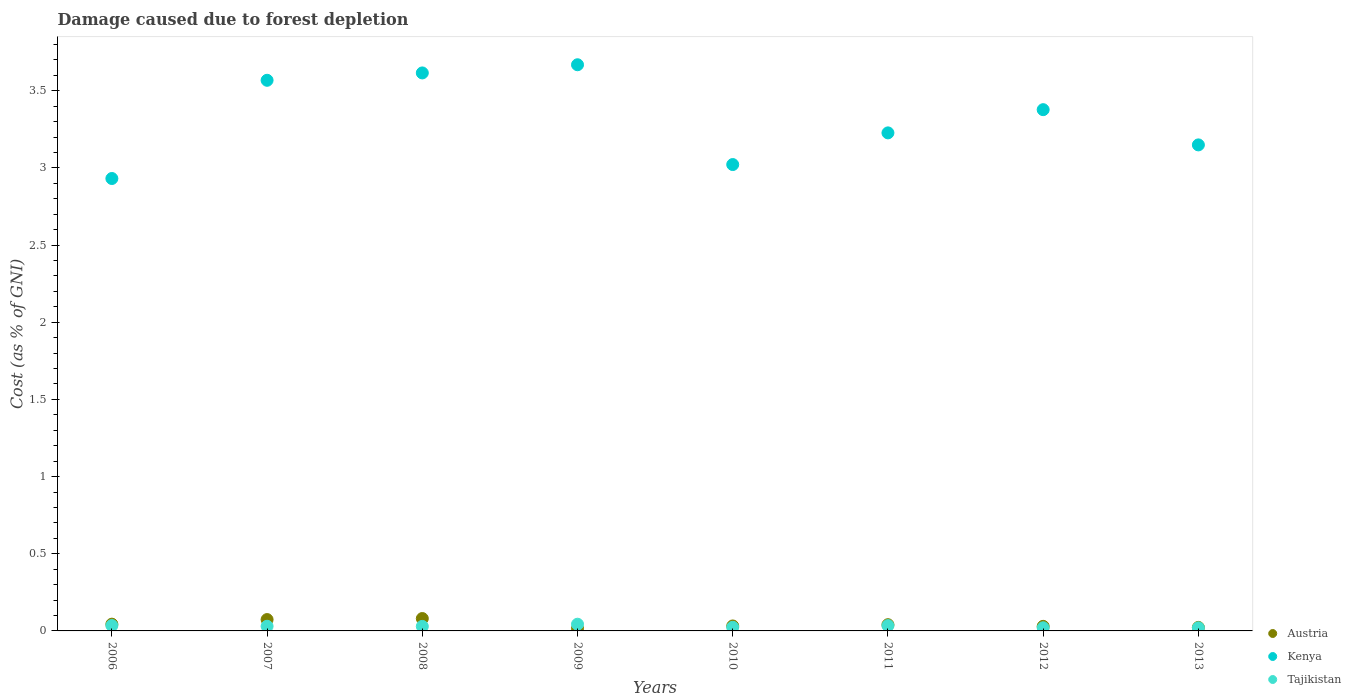How many different coloured dotlines are there?
Your answer should be very brief. 3. What is the cost of damage caused due to forest depletion in Kenya in 2007?
Keep it short and to the point. 3.57. Across all years, what is the maximum cost of damage caused due to forest depletion in Kenya?
Give a very brief answer. 3.67. Across all years, what is the minimum cost of damage caused due to forest depletion in Tajikistan?
Keep it short and to the point. 0.02. In which year was the cost of damage caused due to forest depletion in Tajikistan minimum?
Keep it short and to the point. 2013. What is the total cost of damage caused due to forest depletion in Tajikistan in the graph?
Offer a very short reply. 0.24. What is the difference between the cost of damage caused due to forest depletion in Austria in 2008 and that in 2010?
Ensure brevity in your answer.  0.05. What is the difference between the cost of damage caused due to forest depletion in Kenya in 2011 and the cost of damage caused due to forest depletion in Austria in 2009?
Provide a succinct answer. 3.21. What is the average cost of damage caused due to forest depletion in Tajikistan per year?
Your answer should be compact. 0.03. In the year 2012, what is the difference between the cost of damage caused due to forest depletion in Tajikistan and cost of damage caused due to forest depletion in Austria?
Your answer should be compact. -0.01. What is the ratio of the cost of damage caused due to forest depletion in Austria in 2012 to that in 2013?
Offer a very short reply. 1.3. Is the cost of damage caused due to forest depletion in Austria in 2007 less than that in 2008?
Provide a succinct answer. Yes. What is the difference between the highest and the second highest cost of damage caused due to forest depletion in Tajikistan?
Provide a succinct answer. 0.01. What is the difference between the highest and the lowest cost of damage caused due to forest depletion in Austria?
Make the answer very short. 0.06. Does the cost of damage caused due to forest depletion in Tajikistan monotonically increase over the years?
Offer a terse response. No. Is the cost of damage caused due to forest depletion in Tajikistan strictly greater than the cost of damage caused due to forest depletion in Austria over the years?
Give a very brief answer. No. How many dotlines are there?
Provide a short and direct response. 3. What is the difference between two consecutive major ticks on the Y-axis?
Your answer should be very brief. 0.5. Are the values on the major ticks of Y-axis written in scientific E-notation?
Your answer should be compact. No. Does the graph contain any zero values?
Your answer should be very brief. No. How are the legend labels stacked?
Offer a terse response. Vertical. What is the title of the graph?
Your response must be concise. Damage caused due to forest depletion. Does "Isle of Man" appear as one of the legend labels in the graph?
Your response must be concise. No. What is the label or title of the Y-axis?
Your response must be concise. Cost (as % of GNI). What is the Cost (as % of GNI) of Austria in 2006?
Offer a terse response. 0.04. What is the Cost (as % of GNI) in Kenya in 2006?
Provide a short and direct response. 2.93. What is the Cost (as % of GNI) of Tajikistan in 2006?
Provide a short and direct response. 0.03. What is the Cost (as % of GNI) in Austria in 2007?
Ensure brevity in your answer.  0.07. What is the Cost (as % of GNI) in Kenya in 2007?
Make the answer very short. 3.57. What is the Cost (as % of GNI) of Tajikistan in 2007?
Your answer should be compact. 0.03. What is the Cost (as % of GNI) of Austria in 2008?
Keep it short and to the point. 0.08. What is the Cost (as % of GNI) of Kenya in 2008?
Provide a succinct answer. 3.62. What is the Cost (as % of GNI) of Tajikistan in 2008?
Keep it short and to the point. 0.03. What is the Cost (as % of GNI) of Austria in 2009?
Your response must be concise. 0.02. What is the Cost (as % of GNI) in Kenya in 2009?
Offer a terse response. 3.67. What is the Cost (as % of GNI) in Tajikistan in 2009?
Give a very brief answer. 0.04. What is the Cost (as % of GNI) of Austria in 2010?
Keep it short and to the point. 0.03. What is the Cost (as % of GNI) of Kenya in 2010?
Your response must be concise. 3.02. What is the Cost (as % of GNI) of Tajikistan in 2010?
Ensure brevity in your answer.  0.02. What is the Cost (as % of GNI) of Austria in 2011?
Give a very brief answer. 0.04. What is the Cost (as % of GNI) of Kenya in 2011?
Provide a short and direct response. 3.23. What is the Cost (as % of GNI) in Tajikistan in 2011?
Provide a short and direct response. 0.03. What is the Cost (as % of GNI) of Austria in 2012?
Offer a terse response. 0.03. What is the Cost (as % of GNI) in Kenya in 2012?
Your answer should be compact. 3.38. What is the Cost (as % of GNI) in Tajikistan in 2012?
Offer a terse response. 0.02. What is the Cost (as % of GNI) in Austria in 2013?
Keep it short and to the point. 0.02. What is the Cost (as % of GNI) of Kenya in 2013?
Offer a very short reply. 3.15. What is the Cost (as % of GNI) in Tajikistan in 2013?
Keep it short and to the point. 0.02. Across all years, what is the maximum Cost (as % of GNI) in Austria?
Provide a succinct answer. 0.08. Across all years, what is the maximum Cost (as % of GNI) of Kenya?
Make the answer very short. 3.67. Across all years, what is the maximum Cost (as % of GNI) in Tajikistan?
Your response must be concise. 0.04. Across all years, what is the minimum Cost (as % of GNI) of Austria?
Your answer should be compact. 0.02. Across all years, what is the minimum Cost (as % of GNI) of Kenya?
Your answer should be compact. 2.93. Across all years, what is the minimum Cost (as % of GNI) in Tajikistan?
Ensure brevity in your answer.  0.02. What is the total Cost (as % of GNI) in Austria in the graph?
Ensure brevity in your answer.  0.34. What is the total Cost (as % of GNI) in Kenya in the graph?
Keep it short and to the point. 26.56. What is the total Cost (as % of GNI) in Tajikistan in the graph?
Give a very brief answer. 0.24. What is the difference between the Cost (as % of GNI) of Austria in 2006 and that in 2007?
Offer a very short reply. -0.03. What is the difference between the Cost (as % of GNI) in Kenya in 2006 and that in 2007?
Make the answer very short. -0.64. What is the difference between the Cost (as % of GNI) of Tajikistan in 2006 and that in 2007?
Offer a terse response. 0. What is the difference between the Cost (as % of GNI) in Austria in 2006 and that in 2008?
Provide a succinct answer. -0.04. What is the difference between the Cost (as % of GNI) in Kenya in 2006 and that in 2008?
Ensure brevity in your answer.  -0.68. What is the difference between the Cost (as % of GNI) of Tajikistan in 2006 and that in 2008?
Provide a short and direct response. 0.01. What is the difference between the Cost (as % of GNI) in Austria in 2006 and that in 2009?
Make the answer very short. 0.03. What is the difference between the Cost (as % of GNI) of Kenya in 2006 and that in 2009?
Keep it short and to the point. -0.74. What is the difference between the Cost (as % of GNI) of Tajikistan in 2006 and that in 2009?
Your answer should be very brief. -0.01. What is the difference between the Cost (as % of GNI) of Austria in 2006 and that in 2010?
Your response must be concise. 0.01. What is the difference between the Cost (as % of GNI) in Kenya in 2006 and that in 2010?
Your answer should be compact. -0.09. What is the difference between the Cost (as % of GNI) in Tajikistan in 2006 and that in 2010?
Provide a short and direct response. 0.01. What is the difference between the Cost (as % of GNI) of Austria in 2006 and that in 2011?
Your answer should be compact. 0. What is the difference between the Cost (as % of GNI) in Kenya in 2006 and that in 2011?
Your answer should be compact. -0.3. What is the difference between the Cost (as % of GNI) of Tajikistan in 2006 and that in 2011?
Your answer should be very brief. 0. What is the difference between the Cost (as % of GNI) of Austria in 2006 and that in 2012?
Offer a terse response. 0.01. What is the difference between the Cost (as % of GNI) of Kenya in 2006 and that in 2012?
Keep it short and to the point. -0.45. What is the difference between the Cost (as % of GNI) in Tajikistan in 2006 and that in 2012?
Your answer should be very brief. 0.01. What is the difference between the Cost (as % of GNI) of Austria in 2006 and that in 2013?
Offer a very short reply. 0.02. What is the difference between the Cost (as % of GNI) of Kenya in 2006 and that in 2013?
Offer a very short reply. -0.22. What is the difference between the Cost (as % of GNI) in Tajikistan in 2006 and that in 2013?
Keep it short and to the point. 0.01. What is the difference between the Cost (as % of GNI) in Austria in 2007 and that in 2008?
Offer a very short reply. -0.01. What is the difference between the Cost (as % of GNI) of Kenya in 2007 and that in 2008?
Provide a succinct answer. -0.05. What is the difference between the Cost (as % of GNI) of Tajikistan in 2007 and that in 2008?
Keep it short and to the point. 0. What is the difference between the Cost (as % of GNI) of Austria in 2007 and that in 2009?
Offer a very short reply. 0.06. What is the difference between the Cost (as % of GNI) of Kenya in 2007 and that in 2009?
Your answer should be very brief. -0.1. What is the difference between the Cost (as % of GNI) in Tajikistan in 2007 and that in 2009?
Give a very brief answer. -0.01. What is the difference between the Cost (as % of GNI) in Austria in 2007 and that in 2010?
Your answer should be very brief. 0.04. What is the difference between the Cost (as % of GNI) in Kenya in 2007 and that in 2010?
Make the answer very short. 0.55. What is the difference between the Cost (as % of GNI) in Tajikistan in 2007 and that in 2010?
Ensure brevity in your answer.  0.01. What is the difference between the Cost (as % of GNI) in Kenya in 2007 and that in 2011?
Make the answer very short. 0.34. What is the difference between the Cost (as % of GNI) of Tajikistan in 2007 and that in 2011?
Your answer should be compact. -0. What is the difference between the Cost (as % of GNI) in Austria in 2007 and that in 2012?
Keep it short and to the point. 0.04. What is the difference between the Cost (as % of GNI) in Kenya in 2007 and that in 2012?
Provide a short and direct response. 0.19. What is the difference between the Cost (as % of GNI) of Tajikistan in 2007 and that in 2012?
Make the answer very short. 0.01. What is the difference between the Cost (as % of GNI) in Austria in 2007 and that in 2013?
Keep it short and to the point. 0.05. What is the difference between the Cost (as % of GNI) in Kenya in 2007 and that in 2013?
Give a very brief answer. 0.42. What is the difference between the Cost (as % of GNI) in Tajikistan in 2007 and that in 2013?
Ensure brevity in your answer.  0.01. What is the difference between the Cost (as % of GNI) in Austria in 2008 and that in 2009?
Provide a short and direct response. 0.06. What is the difference between the Cost (as % of GNI) in Kenya in 2008 and that in 2009?
Provide a short and direct response. -0.05. What is the difference between the Cost (as % of GNI) of Tajikistan in 2008 and that in 2009?
Provide a succinct answer. -0.01. What is the difference between the Cost (as % of GNI) of Austria in 2008 and that in 2010?
Offer a very short reply. 0.05. What is the difference between the Cost (as % of GNI) of Kenya in 2008 and that in 2010?
Offer a very short reply. 0.59. What is the difference between the Cost (as % of GNI) of Tajikistan in 2008 and that in 2010?
Provide a succinct answer. 0.01. What is the difference between the Cost (as % of GNI) in Austria in 2008 and that in 2011?
Keep it short and to the point. 0.04. What is the difference between the Cost (as % of GNI) of Kenya in 2008 and that in 2011?
Make the answer very short. 0.39. What is the difference between the Cost (as % of GNI) in Tajikistan in 2008 and that in 2011?
Your answer should be very brief. -0.01. What is the difference between the Cost (as % of GNI) in Austria in 2008 and that in 2012?
Your answer should be compact. 0.05. What is the difference between the Cost (as % of GNI) in Kenya in 2008 and that in 2012?
Provide a succinct answer. 0.24. What is the difference between the Cost (as % of GNI) in Tajikistan in 2008 and that in 2012?
Ensure brevity in your answer.  0.01. What is the difference between the Cost (as % of GNI) in Austria in 2008 and that in 2013?
Offer a very short reply. 0.06. What is the difference between the Cost (as % of GNI) of Kenya in 2008 and that in 2013?
Offer a terse response. 0.47. What is the difference between the Cost (as % of GNI) of Tajikistan in 2008 and that in 2013?
Keep it short and to the point. 0.01. What is the difference between the Cost (as % of GNI) of Austria in 2009 and that in 2010?
Your answer should be very brief. -0.02. What is the difference between the Cost (as % of GNI) in Kenya in 2009 and that in 2010?
Offer a terse response. 0.65. What is the difference between the Cost (as % of GNI) in Tajikistan in 2009 and that in 2010?
Your answer should be very brief. 0.02. What is the difference between the Cost (as % of GNI) in Austria in 2009 and that in 2011?
Keep it short and to the point. -0.02. What is the difference between the Cost (as % of GNI) in Kenya in 2009 and that in 2011?
Give a very brief answer. 0.44. What is the difference between the Cost (as % of GNI) in Tajikistan in 2009 and that in 2011?
Provide a succinct answer. 0.01. What is the difference between the Cost (as % of GNI) of Austria in 2009 and that in 2012?
Keep it short and to the point. -0.01. What is the difference between the Cost (as % of GNI) of Kenya in 2009 and that in 2012?
Your response must be concise. 0.29. What is the difference between the Cost (as % of GNI) of Tajikistan in 2009 and that in 2012?
Your response must be concise. 0.02. What is the difference between the Cost (as % of GNI) in Austria in 2009 and that in 2013?
Offer a terse response. -0.01. What is the difference between the Cost (as % of GNI) in Kenya in 2009 and that in 2013?
Give a very brief answer. 0.52. What is the difference between the Cost (as % of GNI) in Tajikistan in 2009 and that in 2013?
Your answer should be very brief. 0.02. What is the difference between the Cost (as % of GNI) in Austria in 2010 and that in 2011?
Give a very brief answer. -0.01. What is the difference between the Cost (as % of GNI) of Kenya in 2010 and that in 2011?
Provide a short and direct response. -0.21. What is the difference between the Cost (as % of GNI) of Tajikistan in 2010 and that in 2011?
Your answer should be very brief. -0.01. What is the difference between the Cost (as % of GNI) in Austria in 2010 and that in 2012?
Provide a short and direct response. 0. What is the difference between the Cost (as % of GNI) in Kenya in 2010 and that in 2012?
Your answer should be compact. -0.36. What is the difference between the Cost (as % of GNI) of Tajikistan in 2010 and that in 2012?
Give a very brief answer. 0. What is the difference between the Cost (as % of GNI) of Austria in 2010 and that in 2013?
Your answer should be very brief. 0.01. What is the difference between the Cost (as % of GNI) in Kenya in 2010 and that in 2013?
Your answer should be very brief. -0.13. What is the difference between the Cost (as % of GNI) of Tajikistan in 2010 and that in 2013?
Offer a terse response. 0. What is the difference between the Cost (as % of GNI) in Austria in 2011 and that in 2012?
Make the answer very short. 0.01. What is the difference between the Cost (as % of GNI) in Kenya in 2011 and that in 2012?
Your answer should be compact. -0.15. What is the difference between the Cost (as % of GNI) in Tajikistan in 2011 and that in 2012?
Make the answer very short. 0.01. What is the difference between the Cost (as % of GNI) in Austria in 2011 and that in 2013?
Offer a terse response. 0.02. What is the difference between the Cost (as % of GNI) in Kenya in 2011 and that in 2013?
Your answer should be very brief. 0.08. What is the difference between the Cost (as % of GNI) in Tajikistan in 2011 and that in 2013?
Your response must be concise. 0.01. What is the difference between the Cost (as % of GNI) of Austria in 2012 and that in 2013?
Give a very brief answer. 0.01. What is the difference between the Cost (as % of GNI) of Kenya in 2012 and that in 2013?
Offer a very short reply. 0.23. What is the difference between the Cost (as % of GNI) in Austria in 2006 and the Cost (as % of GNI) in Kenya in 2007?
Keep it short and to the point. -3.52. What is the difference between the Cost (as % of GNI) in Austria in 2006 and the Cost (as % of GNI) in Tajikistan in 2007?
Make the answer very short. 0.01. What is the difference between the Cost (as % of GNI) of Kenya in 2006 and the Cost (as % of GNI) of Tajikistan in 2007?
Provide a succinct answer. 2.9. What is the difference between the Cost (as % of GNI) of Austria in 2006 and the Cost (as % of GNI) of Kenya in 2008?
Your answer should be very brief. -3.57. What is the difference between the Cost (as % of GNI) of Austria in 2006 and the Cost (as % of GNI) of Tajikistan in 2008?
Keep it short and to the point. 0.01. What is the difference between the Cost (as % of GNI) in Kenya in 2006 and the Cost (as % of GNI) in Tajikistan in 2008?
Provide a short and direct response. 2.9. What is the difference between the Cost (as % of GNI) of Austria in 2006 and the Cost (as % of GNI) of Kenya in 2009?
Offer a very short reply. -3.62. What is the difference between the Cost (as % of GNI) of Austria in 2006 and the Cost (as % of GNI) of Tajikistan in 2009?
Make the answer very short. 0. What is the difference between the Cost (as % of GNI) of Kenya in 2006 and the Cost (as % of GNI) of Tajikistan in 2009?
Offer a very short reply. 2.89. What is the difference between the Cost (as % of GNI) of Austria in 2006 and the Cost (as % of GNI) of Kenya in 2010?
Give a very brief answer. -2.98. What is the difference between the Cost (as % of GNI) of Austria in 2006 and the Cost (as % of GNI) of Tajikistan in 2010?
Your response must be concise. 0.02. What is the difference between the Cost (as % of GNI) of Kenya in 2006 and the Cost (as % of GNI) of Tajikistan in 2010?
Offer a terse response. 2.91. What is the difference between the Cost (as % of GNI) in Austria in 2006 and the Cost (as % of GNI) in Kenya in 2011?
Ensure brevity in your answer.  -3.18. What is the difference between the Cost (as % of GNI) of Austria in 2006 and the Cost (as % of GNI) of Tajikistan in 2011?
Make the answer very short. 0.01. What is the difference between the Cost (as % of GNI) in Kenya in 2006 and the Cost (as % of GNI) in Tajikistan in 2011?
Your answer should be compact. 2.9. What is the difference between the Cost (as % of GNI) of Austria in 2006 and the Cost (as % of GNI) of Kenya in 2012?
Ensure brevity in your answer.  -3.33. What is the difference between the Cost (as % of GNI) in Austria in 2006 and the Cost (as % of GNI) in Tajikistan in 2012?
Your answer should be very brief. 0.02. What is the difference between the Cost (as % of GNI) in Kenya in 2006 and the Cost (as % of GNI) in Tajikistan in 2012?
Your answer should be compact. 2.91. What is the difference between the Cost (as % of GNI) of Austria in 2006 and the Cost (as % of GNI) of Kenya in 2013?
Make the answer very short. -3.11. What is the difference between the Cost (as % of GNI) of Austria in 2006 and the Cost (as % of GNI) of Tajikistan in 2013?
Your response must be concise. 0.02. What is the difference between the Cost (as % of GNI) in Kenya in 2006 and the Cost (as % of GNI) in Tajikistan in 2013?
Provide a short and direct response. 2.91. What is the difference between the Cost (as % of GNI) in Austria in 2007 and the Cost (as % of GNI) in Kenya in 2008?
Offer a terse response. -3.54. What is the difference between the Cost (as % of GNI) in Austria in 2007 and the Cost (as % of GNI) in Tajikistan in 2008?
Your answer should be very brief. 0.04. What is the difference between the Cost (as % of GNI) in Kenya in 2007 and the Cost (as % of GNI) in Tajikistan in 2008?
Provide a short and direct response. 3.54. What is the difference between the Cost (as % of GNI) of Austria in 2007 and the Cost (as % of GNI) of Kenya in 2009?
Ensure brevity in your answer.  -3.59. What is the difference between the Cost (as % of GNI) of Austria in 2007 and the Cost (as % of GNI) of Tajikistan in 2009?
Your answer should be very brief. 0.03. What is the difference between the Cost (as % of GNI) in Kenya in 2007 and the Cost (as % of GNI) in Tajikistan in 2009?
Provide a succinct answer. 3.52. What is the difference between the Cost (as % of GNI) in Austria in 2007 and the Cost (as % of GNI) in Kenya in 2010?
Give a very brief answer. -2.95. What is the difference between the Cost (as % of GNI) in Austria in 2007 and the Cost (as % of GNI) in Tajikistan in 2010?
Offer a terse response. 0.05. What is the difference between the Cost (as % of GNI) of Kenya in 2007 and the Cost (as % of GNI) of Tajikistan in 2010?
Offer a very short reply. 3.54. What is the difference between the Cost (as % of GNI) of Austria in 2007 and the Cost (as % of GNI) of Kenya in 2011?
Make the answer very short. -3.15. What is the difference between the Cost (as % of GNI) of Austria in 2007 and the Cost (as % of GNI) of Tajikistan in 2011?
Make the answer very short. 0.04. What is the difference between the Cost (as % of GNI) of Kenya in 2007 and the Cost (as % of GNI) of Tajikistan in 2011?
Provide a succinct answer. 3.53. What is the difference between the Cost (as % of GNI) in Austria in 2007 and the Cost (as % of GNI) in Kenya in 2012?
Ensure brevity in your answer.  -3.3. What is the difference between the Cost (as % of GNI) of Austria in 2007 and the Cost (as % of GNI) of Tajikistan in 2012?
Offer a very short reply. 0.05. What is the difference between the Cost (as % of GNI) of Kenya in 2007 and the Cost (as % of GNI) of Tajikistan in 2012?
Keep it short and to the point. 3.55. What is the difference between the Cost (as % of GNI) of Austria in 2007 and the Cost (as % of GNI) of Kenya in 2013?
Make the answer very short. -3.08. What is the difference between the Cost (as % of GNI) of Austria in 2007 and the Cost (as % of GNI) of Tajikistan in 2013?
Provide a short and direct response. 0.05. What is the difference between the Cost (as % of GNI) in Kenya in 2007 and the Cost (as % of GNI) in Tajikistan in 2013?
Keep it short and to the point. 3.55. What is the difference between the Cost (as % of GNI) in Austria in 2008 and the Cost (as % of GNI) in Kenya in 2009?
Provide a succinct answer. -3.59. What is the difference between the Cost (as % of GNI) in Austria in 2008 and the Cost (as % of GNI) in Tajikistan in 2009?
Ensure brevity in your answer.  0.04. What is the difference between the Cost (as % of GNI) in Kenya in 2008 and the Cost (as % of GNI) in Tajikistan in 2009?
Your answer should be very brief. 3.57. What is the difference between the Cost (as % of GNI) in Austria in 2008 and the Cost (as % of GNI) in Kenya in 2010?
Your response must be concise. -2.94. What is the difference between the Cost (as % of GNI) in Austria in 2008 and the Cost (as % of GNI) in Tajikistan in 2010?
Ensure brevity in your answer.  0.06. What is the difference between the Cost (as % of GNI) of Kenya in 2008 and the Cost (as % of GNI) of Tajikistan in 2010?
Offer a terse response. 3.59. What is the difference between the Cost (as % of GNI) in Austria in 2008 and the Cost (as % of GNI) in Kenya in 2011?
Offer a very short reply. -3.15. What is the difference between the Cost (as % of GNI) of Austria in 2008 and the Cost (as % of GNI) of Tajikistan in 2011?
Offer a very short reply. 0.05. What is the difference between the Cost (as % of GNI) of Kenya in 2008 and the Cost (as % of GNI) of Tajikistan in 2011?
Give a very brief answer. 3.58. What is the difference between the Cost (as % of GNI) of Austria in 2008 and the Cost (as % of GNI) of Kenya in 2012?
Keep it short and to the point. -3.3. What is the difference between the Cost (as % of GNI) of Austria in 2008 and the Cost (as % of GNI) of Tajikistan in 2012?
Your answer should be compact. 0.06. What is the difference between the Cost (as % of GNI) in Kenya in 2008 and the Cost (as % of GNI) in Tajikistan in 2012?
Give a very brief answer. 3.6. What is the difference between the Cost (as % of GNI) in Austria in 2008 and the Cost (as % of GNI) in Kenya in 2013?
Your answer should be very brief. -3.07. What is the difference between the Cost (as % of GNI) in Austria in 2008 and the Cost (as % of GNI) in Tajikistan in 2013?
Ensure brevity in your answer.  0.06. What is the difference between the Cost (as % of GNI) of Kenya in 2008 and the Cost (as % of GNI) of Tajikistan in 2013?
Provide a short and direct response. 3.6. What is the difference between the Cost (as % of GNI) of Austria in 2009 and the Cost (as % of GNI) of Kenya in 2010?
Make the answer very short. -3.01. What is the difference between the Cost (as % of GNI) in Austria in 2009 and the Cost (as % of GNI) in Tajikistan in 2010?
Make the answer very short. -0.01. What is the difference between the Cost (as % of GNI) of Kenya in 2009 and the Cost (as % of GNI) of Tajikistan in 2010?
Make the answer very short. 3.64. What is the difference between the Cost (as % of GNI) of Austria in 2009 and the Cost (as % of GNI) of Kenya in 2011?
Make the answer very short. -3.21. What is the difference between the Cost (as % of GNI) of Austria in 2009 and the Cost (as % of GNI) of Tajikistan in 2011?
Ensure brevity in your answer.  -0.02. What is the difference between the Cost (as % of GNI) in Kenya in 2009 and the Cost (as % of GNI) in Tajikistan in 2011?
Keep it short and to the point. 3.63. What is the difference between the Cost (as % of GNI) in Austria in 2009 and the Cost (as % of GNI) in Kenya in 2012?
Make the answer very short. -3.36. What is the difference between the Cost (as % of GNI) of Austria in 2009 and the Cost (as % of GNI) of Tajikistan in 2012?
Your response must be concise. -0. What is the difference between the Cost (as % of GNI) of Kenya in 2009 and the Cost (as % of GNI) of Tajikistan in 2012?
Your answer should be compact. 3.65. What is the difference between the Cost (as % of GNI) of Austria in 2009 and the Cost (as % of GNI) of Kenya in 2013?
Ensure brevity in your answer.  -3.13. What is the difference between the Cost (as % of GNI) in Austria in 2009 and the Cost (as % of GNI) in Tajikistan in 2013?
Offer a very short reply. -0. What is the difference between the Cost (as % of GNI) in Kenya in 2009 and the Cost (as % of GNI) in Tajikistan in 2013?
Your answer should be compact. 3.65. What is the difference between the Cost (as % of GNI) of Austria in 2010 and the Cost (as % of GNI) of Kenya in 2011?
Ensure brevity in your answer.  -3.19. What is the difference between the Cost (as % of GNI) in Austria in 2010 and the Cost (as % of GNI) in Tajikistan in 2011?
Offer a very short reply. -0. What is the difference between the Cost (as % of GNI) in Kenya in 2010 and the Cost (as % of GNI) in Tajikistan in 2011?
Make the answer very short. 2.99. What is the difference between the Cost (as % of GNI) in Austria in 2010 and the Cost (as % of GNI) in Kenya in 2012?
Offer a very short reply. -3.35. What is the difference between the Cost (as % of GNI) in Austria in 2010 and the Cost (as % of GNI) in Tajikistan in 2012?
Give a very brief answer. 0.01. What is the difference between the Cost (as % of GNI) in Kenya in 2010 and the Cost (as % of GNI) in Tajikistan in 2012?
Provide a short and direct response. 3. What is the difference between the Cost (as % of GNI) of Austria in 2010 and the Cost (as % of GNI) of Kenya in 2013?
Your response must be concise. -3.12. What is the difference between the Cost (as % of GNI) in Austria in 2010 and the Cost (as % of GNI) in Tajikistan in 2013?
Provide a succinct answer. 0.01. What is the difference between the Cost (as % of GNI) in Kenya in 2010 and the Cost (as % of GNI) in Tajikistan in 2013?
Offer a very short reply. 3. What is the difference between the Cost (as % of GNI) of Austria in 2011 and the Cost (as % of GNI) of Kenya in 2012?
Your response must be concise. -3.34. What is the difference between the Cost (as % of GNI) of Austria in 2011 and the Cost (as % of GNI) of Tajikistan in 2012?
Give a very brief answer. 0.02. What is the difference between the Cost (as % of GNI) in Kenya in 2011 and the Cost (as % of GNI) in Tajikistan in 2012?
Your answer should be very brief. 3.21. What is the difference between the Cost (as % of GNI) of Austria in 2011 and the Cost (as % of GNI) of Kenya in 2013?
Keep it short and to the point. -3.11. What is the difference between the Cost (as % of GNI) of Austria in 2011 and the Cost (as % of GNI) of Tajikistan in 2013?
Keep it short and to the point. 0.02. What is the difference between the Cost (as % of GNI) of Kenya in 2011 and the Cost (as % of GNI) of Tajikistan in 2013?
Offer a very short reply. 3.21. What is the difference between the Cost (as % of GNI) of Austria in 2012 and the Cost (as % of GNI) of Kenya in 2013?
Offer a very short reply. -3.12. What is the difference between the Cost (as % of GNI) of Austria in 2012 and the Cost (as % of GNI) of Tajikistan in 2013?
Your answer should be very brief. 0.01. What is the difference between the Cost (as % of GNI) in Kenya in 2012 and the Cost (as % of GNI) in Tajikistan in 2013?
Your answer should be compact. 3.36. What is the average Cost (as % of GNI) in Austria per year?
Your response must be concise. 0.04. What is the average Cost (as % of GNI) of Kenya per year?
Offer a terse response. 3.32. What is the average Cost (as % of GNI) of Tajikistan per year?
Offer a very short reply. 0.03. In the year 2006, what is the difference between the Cost (as % of GNI) in Austria and Cost (as % of GNI) in Kenya?
Offer a terse response. -2.89. In the year 2006, what is the difference between the Cost (as % of GNI) in Austria and Cost (as % of GNI) in Tajikistan?
Your answer should be very brief. 0.01. In the year 2006, what is the difference between the Cost (as % of GNI) of Kenya and Cost (as % of GNI) of Tajikistan?
Give a very brief answer. 2.9. In the year 2007, what is the difference between the Cost (as % of GNI) in Austria and Cost (as % of GNI) in Kenya?
Provide a succinct answer. -3.49. In the year 2007, what is the difference between the Cost (as % of GNI) in Austria and Cost (as % of GNI) in Tajikistan?
Make the answer very short. 0.04. In the year 2007, what is the difference between the Cost (as % of GNI) of Kenya and Cost (as % of GNI) of Tajikistan?
Offer a terse response. 3.54. In the year 2008, what is the difference between the Cost (as % of GNI) of Austria and Cost (as % of GNI) of Kenya?
Ensure brevity in your answer.  -3.54. In the year 2008, what is the difference between the Cost (as % of GNI) of Austria and Cost (as % of GNI) of Tajikistan?
Make the answer very short. 0.05. In the year 2008, what is the difference between the Cost (as % of GNI) of Kenya and Cost (as % of GNI) of Tajikistan?
Make the answer very short. 3.59. In the year 2009, what is the difference between the Cost (as % of GNI) of Austria and Cost (as % of GNI) of Kenya?
Give a very brief answer. -3.65. In the year 2009, what is the difference between the Cost (as % of GNI) of Austria and Cost (as % of GNI) of Tajikistan?
Make the answer very short. -0.03. In the year 2009, what is the difference between the Cost (as % of GNI) in Kenya and Cost (as % of GNI) in Tajikistan?
Your answer should be compact. 3.62. In the year 2010, what is the difference between the Cost (as % of GNI) of Austria and Cost (as % of GNI) of Kenya?
Your answer should be very brief. -2.99. In the year 2010, what is the difference between the Cost (as % of GNI) of Austria and Cost (as % of GNI) of Tajikistan?
Make the answer very short. 0.01. In the year 2010, what is the difference between the Cost (as % of GNI) of Kenya and Cost (as % of GNI) of Tajikistan?
Provide a short and direct response. 3. In the year 2011, what is the difference between the Cost (as % of GNI) of Austria and Cost (as % of GNI) of Kenya?
Provide a short and direct response. -3.19. In the year 2011, what is the difference between the Cost (as % of GNI) of Austria and Cost (as % of GNI) of Tajikistan?
Offer a very short reply. 0.01. In the year 2011, what is the difference between the Cost (as % of GNI) in Kenya and Cost (as % of GNI) in Tajikistan?
Ensure brevity in your answer.  3.19. In the year 2012, what is the difference between the Cost (as % of GNI) in Austria and Cost (as % of GNI) in Kenya?
Provide a succinct answer. -3.35. In the year 2012, what is the difference between the Cost (as % of GNI) of Austria and Cost (as % of GNI) of Tajikistan?
Your answer should be very brief. 0.01. In the year 2012, what is the difference between the Cost (as % of GNI) in Kenya and Cost (as % of GNI) in Tajikistan?
Give a very brief answer. 3.36. In the year 2013, what is the difference between the Cost (as % of GNI) in Austria and Cost (as % of GNI) in Kenya?
Offer a terse response. -3.13. In the year 2013, what is the difference between the Cost (as % of GNI) in Austria and Cost (as % of GNI) in Tajikistan?
Make the answer very short. 0. In the year 2013, what is the difference between the Cost (as % of GNI) of Kenya and Cost (as % of GNI) of Tajikistan?
Offer a terse response. 3.13. What is the ratio of the Cost (as % of GNI) in Austria in 2006 to that in 2007?
Make the answer very short. 0.59. What is the ratio of the Cost (as % of GNI) in Kenya in 2006 to that in 2007?
Your answer should be compact. 0.82. What is the ratio of the Cost (as % of GNI) of Tajikistan in 2006 to that in 2007?
Your answer should be compact. 1.16. What is the ratio of the Cost (as % of GNI) of Austria in 2006 to that in 2008?
Offer a terse response. 0.55. What is the ratio of the Cost (as % of GNI) in Kenya in 2006 to that in 2008?
Offer a terse response. 0.81. What is the ratio of the Cost (as % of GNI) in Tajikistan in 2006 to that in 2008?
Your response must be concise. 1.19. What is the ratio of the Cost (as % of GNI) in Austria in 2006 to that in 2009?
Your response must be concise. 2.67. What is the ratio of the Cost (as % of GNI) in Kenya in 2006 to that in 2009?
Your response must be concise. 0.8. What is the ratio of the Cost (as % of GNI) of Tajikistan in 2006 to that in 2009?
Offer a terse response. 0.8. What is the ratio of the Cost (as % of GNI) in Austria in 2006 to that in 2010?
Offer a very short reply. 1.36. What is the ratio of the Cost (as % of GNI) of Kenya in 2006 to that in 2010?
Provide a succinct answer. 0.97. What is the ratio of the Cost (as % of GNI) of Tajikistan in 2006 to that in 2010?
Ensure brevity in your answer.  1.48. What is the ratio of the Cost (as % of GNI) in Austria in 2006 to that in 2011?
Your answer should be very brief. 1.09. What is the ratio of the Cost (as % of GNI) of Kenya in 2006 to that in 2011?
Make the answer very short. 0.91. What is the ratio of the Cost (as % of GNI) of Tajikistan in 2006 to that in 2011?
Provide a succinct answer. 1.01. What is the ratio of the Cost (as % of GNI) in Austria in 2006 to that in 2012?
Your answer should be compact. 1.47. What is the ratio of the Cost (as % of GNI) in Kenya in 2006 to that in 2012?
Your answer should be very brief. 0.87. What is the ratio of the Cost (as % of GNI) in Tajikistan in 2006 to that in 2012?
Provide a succinct answer. 1.71. What is the ratio of the Cost (as % of GNI) of Austria in 2006 to that in 2013?
Your response must be concise. 1.92. What is the ratio of the Cost (as % of GNI) in Kenya in 2006 to that in 2013?
Your response must be concise. 0.93. What is the ratio of the Cost (as % of GNI) in Tajikistan in 2006 to that in 2013?
Give a very brief answer. 1.75. What is the ratio of the Cost (as % of GNI) of Tajikistan in 2007 to that in 2008?
Your answer should be very brief. 1.03. What is the ratio of the Cost (as % of GNI) in Austria in 2007 to that in 2009?
Your response must be concise. 4.49. What is the ratio of the Cost (as % of GNI) in Kenya in 2007 to that in 2009?
Give a very brief answer. 0.97. What is the ratio of the Cost (as % of GNI) in Tajikistan in 2007 to that in 2009?
Offer a terse response. 0.69. What is the ratio of the Cost (as % of GNI) in Austria in 2007 to that in 2010?
Give a very brief answer. 2.29. What is the ratio of the Cost (as % of GNI) of Kenya in 2007 to that in 2010?
Your answer should be compact. 1.18. What is the ratio of the Cost (as % of GNI) of Tajikistan in 2007 to that in 2010?
Provide a succinct answer. 1.28. What is the ratio of the Cost (as % of GNI) in Austria in 2007 to that in 2011?
Keep it short and to the point. 1.82. What is the ratio of the Cost (as % of GNI) in Kenya in 2007 to that in 2011?
Provide a succinct answer. 1.11. What is the ratio of the Cost (as % of GNI) in Tajikistan in 2007 to that in 2011?
Provide a succinct answer. 0.88. What is the ratio of the Cost (as % of GNI) of Austria in 2007 to that in 2012?
Your answer should be compact. 2.48. What is the ratio of the Cost (as % of GNI) of Kenya in 2007 to that in 2012?
Offer a terse response. 1.06. What is the ratio of the Cost (as % of GNI) of Tajikistan in 2007 to that in 2012?
Your answer should be very brief. 1.48. What is the ratio of the Cost (as % of GNI) of Austria in 2007 to that in 2013?
Make the answer very short. 3.23. What is the ratio of the Cost (as % of GNI) of Kenya in 2007 to that in 2013?
Provide a short and direct response. 1.13. What is the ratio of the Cost (as % of GNI) of Tajikistan in 2007 to that in 2013?
Give a very brief answer. 1.51. What is the ratio of the Cost (as % of GNI) of Austria in 2008 to that in 2009?
Provide a succinct answer. 4.9. What is the ratio of the Cost (as % of GNI) in Kenya in 2008 to that in 2009?
Provide a succinct answer. 0.99. What is the ratio of the Cost (as % of GNI) in Tajikistan in 2008 to that in 2009?
Give a very brief answer. 0.67. What is the ratio of the Cost (as % of GNI) in Austria in 2008 to that in 2010?
Your answer should be very brief. 2.49. What is the ratio of the Cost (as % of GNI) of Kenya in 2008 to that in 2010?
Your answer should be compact. 1.2. What is the ratio of the Cost (as % of GNI) in Tajikistan in 2008 to that in 2010?
Provide a succinct answer. 1.24. What is the ratio of the Cost (as % of GNI) in Austria in 2008 to that in 2011?
Ensure brevity in your answer.  1.99. What is the ratio of the Cost (as % of GNI) of Kenya in 2008 to that in 2011?
Give a very brief answer. 1.12. What is the ratio of the Cost (as % of GNI) in Tajikistan in 2008 to that in 2011?
Keep it short and to the point. 0.85. What is the ratio of the Cost (as % of GNI) in Austria in 2008 to that in 2012?
Your answer should be very brief. 2.71. What is the ratio of the Cost (as % of GNI) of Kenya in 2008 to that in 2012?
Your answer should be very brief. 1.07. What is the ratio of the Cost (as % of GNI) of Tajikistan in 2008 to that in 2012?
Offer a very short reply. 1.43. What is the ratio of the Cost (as % of GNI) in Austria in 2008 to that in 2013?
Your answer should be very brief. 3.52. What is the ratio of the Cost (as % of GNI) of Kenya in 2008 to that in 2013?
Keep it short and to the point. 1.15. What is the ratio of the Cost (as % of GNI) of Tajikistan in 2008 to that in 2013?
Make the answer very short. 1.47. What is the ratio of the Cost (as % of GNI) in Austria in 2009 to that in 2010?
Keep it short and to the point. 0.51. What is the ratio of the Cost (as % of GNI) of Kenya in 2009 to that in 2010?
Your answer should be very brief. 1.21. What is the ratio of the Cost (as % of GNI) of Tajikistan in 2009 to that in 2010?
Give a very brief answer. 1.84. What is the ratio of the Cost (as % of GNI) in Austria in 2009 to that in 2011?
Give a very brief answer. 0.41. What is the ratio of the Cost (as % of GNI) in Kenya in 2009 to that in 2011?
Your response must be concise. 1.14. What is the ratio of the Cost (as % of GNI) in Tajikistan in 2009 to that in 2011?
Your answer should be very brief. 1.26. What is the ratio of the Cost (as % of GNI) of Austria in 2009 to that in 2012?
Ensure brevity in your answer.  0.55. What is the ratio of the Cost (as % of GNI) of Kenya in 2009 to that in 2012?
Give a very brief answer. 1.09. What is the ratio of the Cost (as % of GNI) in Tajikistan in 2009 to that in 2012?
Ensure brevity in your answer.  2.13. What is the ratio of the Cost (as % of GNI) of Austria in 2009 to that in 2013?
Provide a short and direct response. 0.72. What is the ratio of the Cost (as % of GNI) in Kenya in 2009 to that in 2013?
Your answer should be compact. 1.16. What is the ratio of the Cost (as % of GNI) in Tajikistan in 2009 to that in 2013?
Your response must be concise. 2.18. What is the ratio of the Cost (as % of GNI) of Austria in 2010 to that in 2011?
Offer a terse response. 0.8. What is the ratio of the Cost (as % of GNI) of Kenya in 2010 to that in 2011?
Make the answer very short. 0.94. What is the ratio of the Cost (as % of GNI) in Tajikistan in 2010 to that in 2011?
Make the answer very short. 0.69. What is the ratio of the Cost (as % of GNI) in Austria in 2010 to that in 2012?
Keep it short and to the point. 1.08. What is the ratio of the Cost (as % of GNI) in Kenya in 2010 to that in 2012?
Keep it short and to the point. 0.89. What is the ratio of the Cost (as % of GNI) in Tajikistan in 2010 to that in 2012?
Give a very brief answer. 1.16. What is the ratio of the Cost (as % of GNI) of Austria in 2010 to that in 2013?
Your response must be concise. 1.41. What is the ratio of the Cost (as % of GNI) of Kenya in 2010 to that in 2013?
Offer a terse response. 0.96. What is the ratio of the Cost (as % of GNI) of Tajikistan in 2010 to that in 2013?
Offer a terse response. 1.18. What is the ratio of the Cost (as % of GNI) of Austria in 2011 to that in 2012?
Provide a succinct answer. 1.36. What is the ratio of the Cost (as % of GNI) in Kenya in 2011 to that in 2012?
Provide a succinct answer. 0.96. What is the ratio of the Cost (as % of GNI) in Tajikistan in 2011 to that in 2012?
Give a very brief answer. 1.68. What is the ratio of the Cost (as % of GNI) of Austria in 2011 to that in 2013?
Keep it short and to the point. 1.77. What is the ratio of the Cost (as % of GNI) in Kenya in 2011 to that in 2013?
Provide a short and direct response. 1.02. What is the ratio of the Cost (as % of GNI) of Tajikistan in 2011 to that in 2013?
Provide a succinct answer. 1.72. What is the ratio of the Cost (as % of GNI) of Austria in 2012 to that in 2013?
Keep it short and to the point. 1.3. What is the ratio of the Cost (as % of GNI) in Kenya in 2012 to that in 2013?
Ensure brevity in your answer.  1.07. What is the ratio of the Cost (as % of GNI) of Tajikistan in 2012 to that in 2013?
Give a very brief answer. 1.03. What is the difference between the highest and the second highest Cost (as % of GNI) in Austria?
Ensure brevity in your answer.  0.01. What is the difference between the highest and the second highest Cost (as % of GNI) of Kenya?
Your response must be concise. 0.05. What is the difference between the highest and the second highest Cost (as % of GNI) of Tajikistan?
Keep it short and to the point. 0.01. What is the difference between the highest and the lowest Cost (as % of GNI) of Austria?
Make the answer very short. 0.06. What is the difference between the highest and the lowest Cost (as % of GNI) in Kenya?
Provide a succinct answer. 0.74. What is the difference between the highest and the lowest Cost (as % of GNI) in Tajikistan?
Offer a terse response. 0.02. 